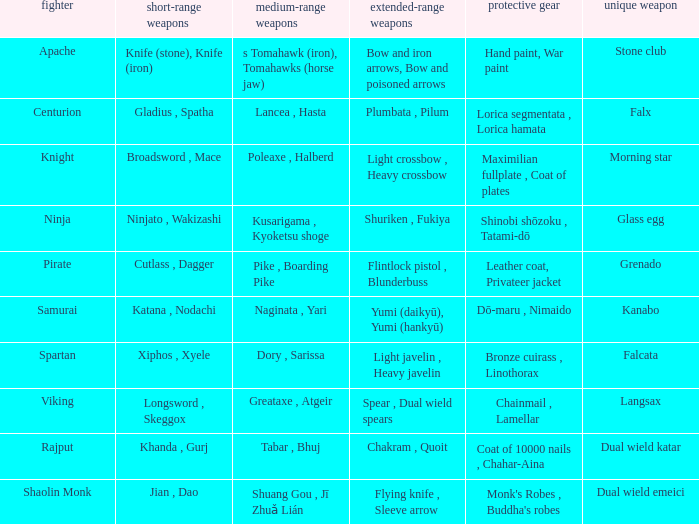If the special weapon is the Grenado, what is the armor? Leather coat, Privateer jacket. Parse the table in full. {'header': ['fighter', 'short-range weapons', 'medium-range weapons', 'extended-range weapons', 'protective gear', 'unique weapon'], 'rows': [['Apache', 'Knife (stone), Knife (iron)', 's Tomahawk (iron), Tomahawks (horse jaw)', 'Bow and iron arrows, Bow and poisoned arrows', 'Hand paint, War paint', 'Stone club'], ['Centurion', 'Gladius , Spatha', 'Lancea , Hasta', 'Plumbata , Pilum', 'Lorica segmentata , Lorica hamata', 'Falx'], ['Knight', 'Broadsword , Mace', 'Poleaxe , Halberd', 'Light crossbow , Heavy crossbow', 'Maximilian fullplate , Coat of plates', 'Morning star'], ['Ninja', 'Ninjato , Wakizashi', 'Kusarigama , Kyoketsu shoge', 'Shuriken , Fukiya', 'Shinobi shōzoku , Tatami-dō', 'Glass egg'], ['Pirate', 'Cutlass , Dagger', 'Pike , Boarding Pike', 'Flintlock pistol , Blunderbuss', 'Leather coat, Privateer jacket', 'Grenado'], ['Samurai', 'Katana , Nodachi', 'Naginata , Yari', 'Yumi (daikyū), Yumi (hankyū)', 'Dō-maru , Nimaido', 'Kanabo'], ['Spartan', 'Xiphos , Xyele', 'Dory , Sarissa', 'Light javelin , Heavy javelin', 'Bronze cuirass , Linothorax', 'Falcata'], ['Viking', 'Longsword , Skeggox', 'Greataxe , Atgeir', 'Spear , Dual wield spears', 'Chainmail , Lamellar', 'Langsax'], ['Rajput', 'Khanda , Gurj', 'Tabar , Bhuj', 'Chakram , Quoit', 'Coat of 10000 nails , Chahar-Aina', 'Dual wield katar'], ['Shaolin Monk', 'Jian , Dao', 'Shuang Gou , Jī Zhuǎ Lián', 'Flying knife , Sleeve arrow', "Monk's Robes , Buddha's robes", 'Dual wield emeici']]} 